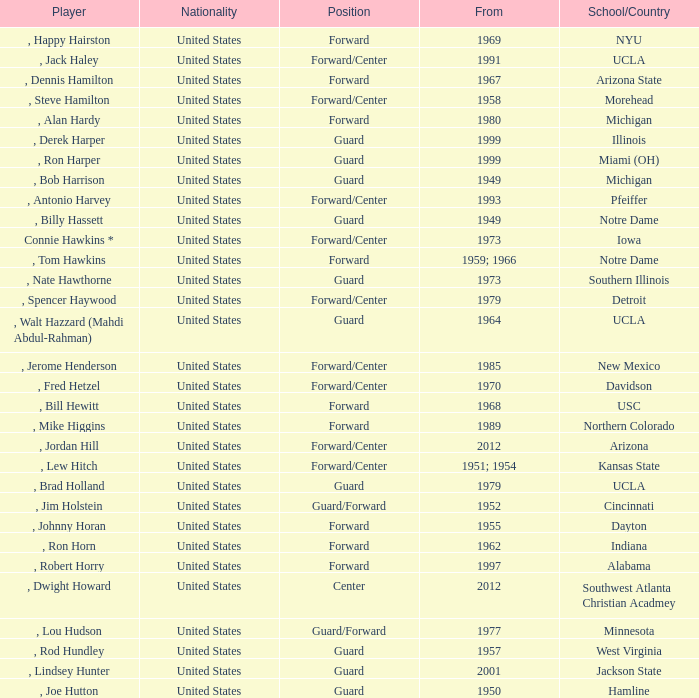Which school has the player that started in 1958? Morehead. 